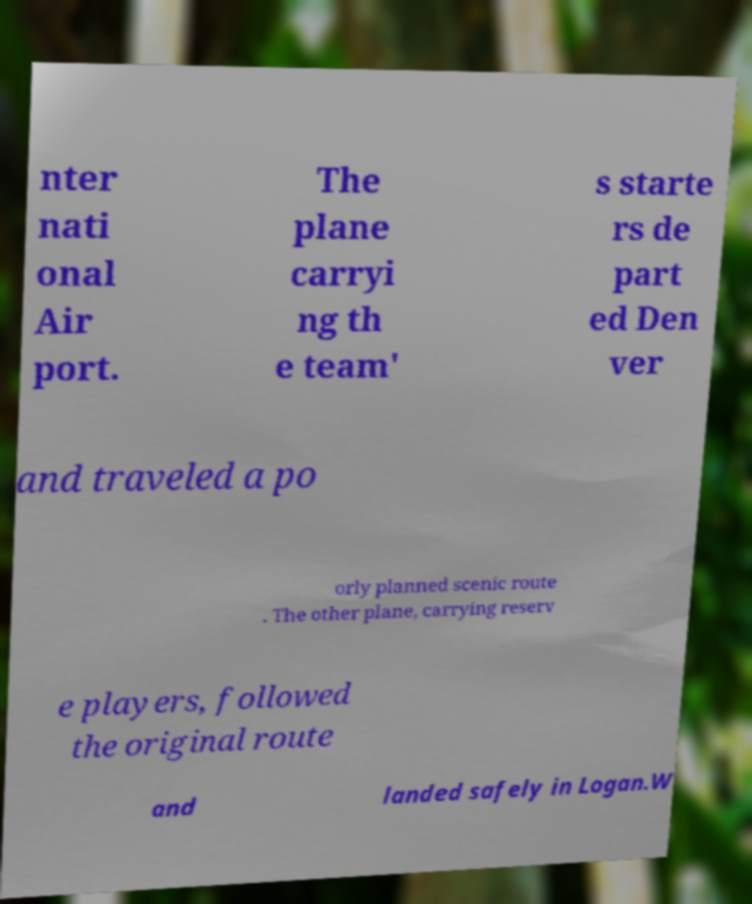Please identify and transcribe the text found in this image. nter nati onal Air port. The plane carryi ng th e team' s starte rs de part ed Den ver and traveled a po orly planned scenic route . The other plane, carrying reserv e players, followed the original route and landed safely in Logan.W 